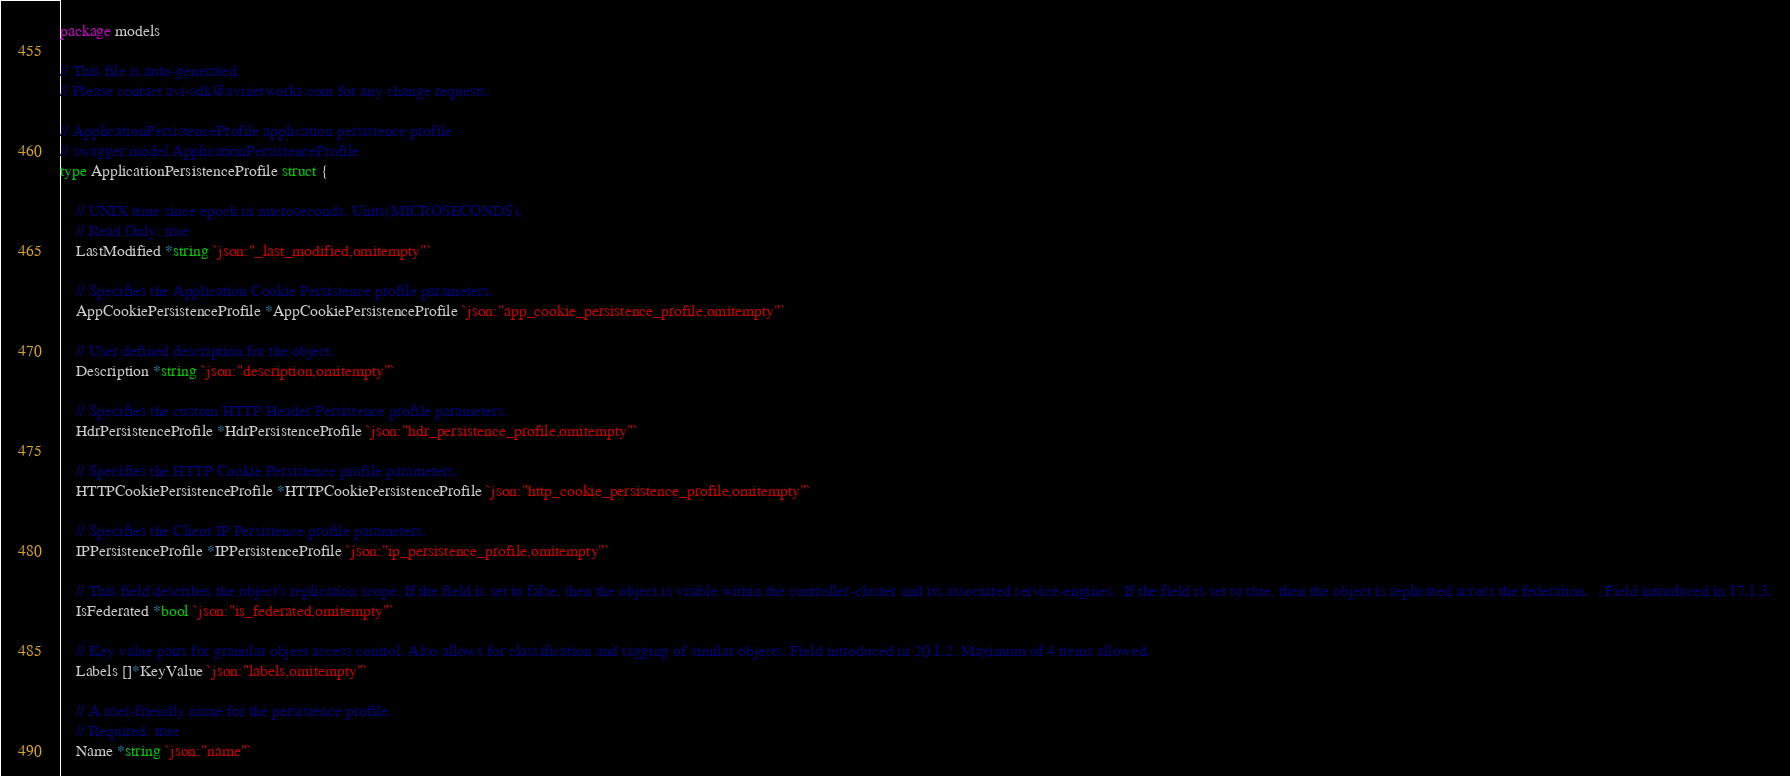Convert code to text. <code><loc_0><loc_0><loc_500><loc_500><_Go_>package models

// This file is auto-generated.
// Please contact avi-sdk@avinetworks.com for any change requests.

// ApplicationPersistenceProfile application persistence profile
// swagger:model ApplicationPersistenceProfile
type ApplicationPersistenceProfile struct {

	// UNIX time since epoch in microseconds. Units(MICROSECONDS).
	// Read Only: true
	LastModified *string `json:"_last_modified,omitempty"`

	// Specifies the Application Cookie Persistence profile parameters.
	AppCookiePersistenceProfile *AppCookiePersistenceProfile `json:"app_cookie_persistence_profile,omitempty"`

	// User defined description for the object.
	Description *string `json:"description,omitempty"`

	// Specifies the custom HTTP Header Persistence profile parameters.
	HdrPersistenceProfile *HdrPersistenceProfile `json:"hdr_persistence_profile,omitempty"`

	// Specifies the HTTP Cookie Persistence profile parameters.
	HTTPCookiePersistenceProfile *HTTPCookiePersistenceProfile `json:"http_cookie_persistence_profile,omitempty"`

	// Specifies the Client IP Persistence profile parameters.
	IPPersistenceProfile *IPPersistenceProfile `json:"ip_persistence_profile,omitempty"`

	// This field describes the object's replication scope. If the field is set to false, then the object is visible within the controller-cluster and its associated service-engines.  If the field is set to true, then the object is replicated across the federation.  . Field introduced in 17.1.3.
	IsFederated *bool `json:"is_federated,omitempty"`

	// Key value pairs for granular object access control. Also allows for classification and tagging of similar objects. Field introduced in 20.1.2. Maximum of 4 items allowed.
	Labels []*KeyValue `json:"labels,omitempty"`

	// A user-friendly name for the persistence profile.
	// Required: true
	Name *string `json:"name"`
</code> 